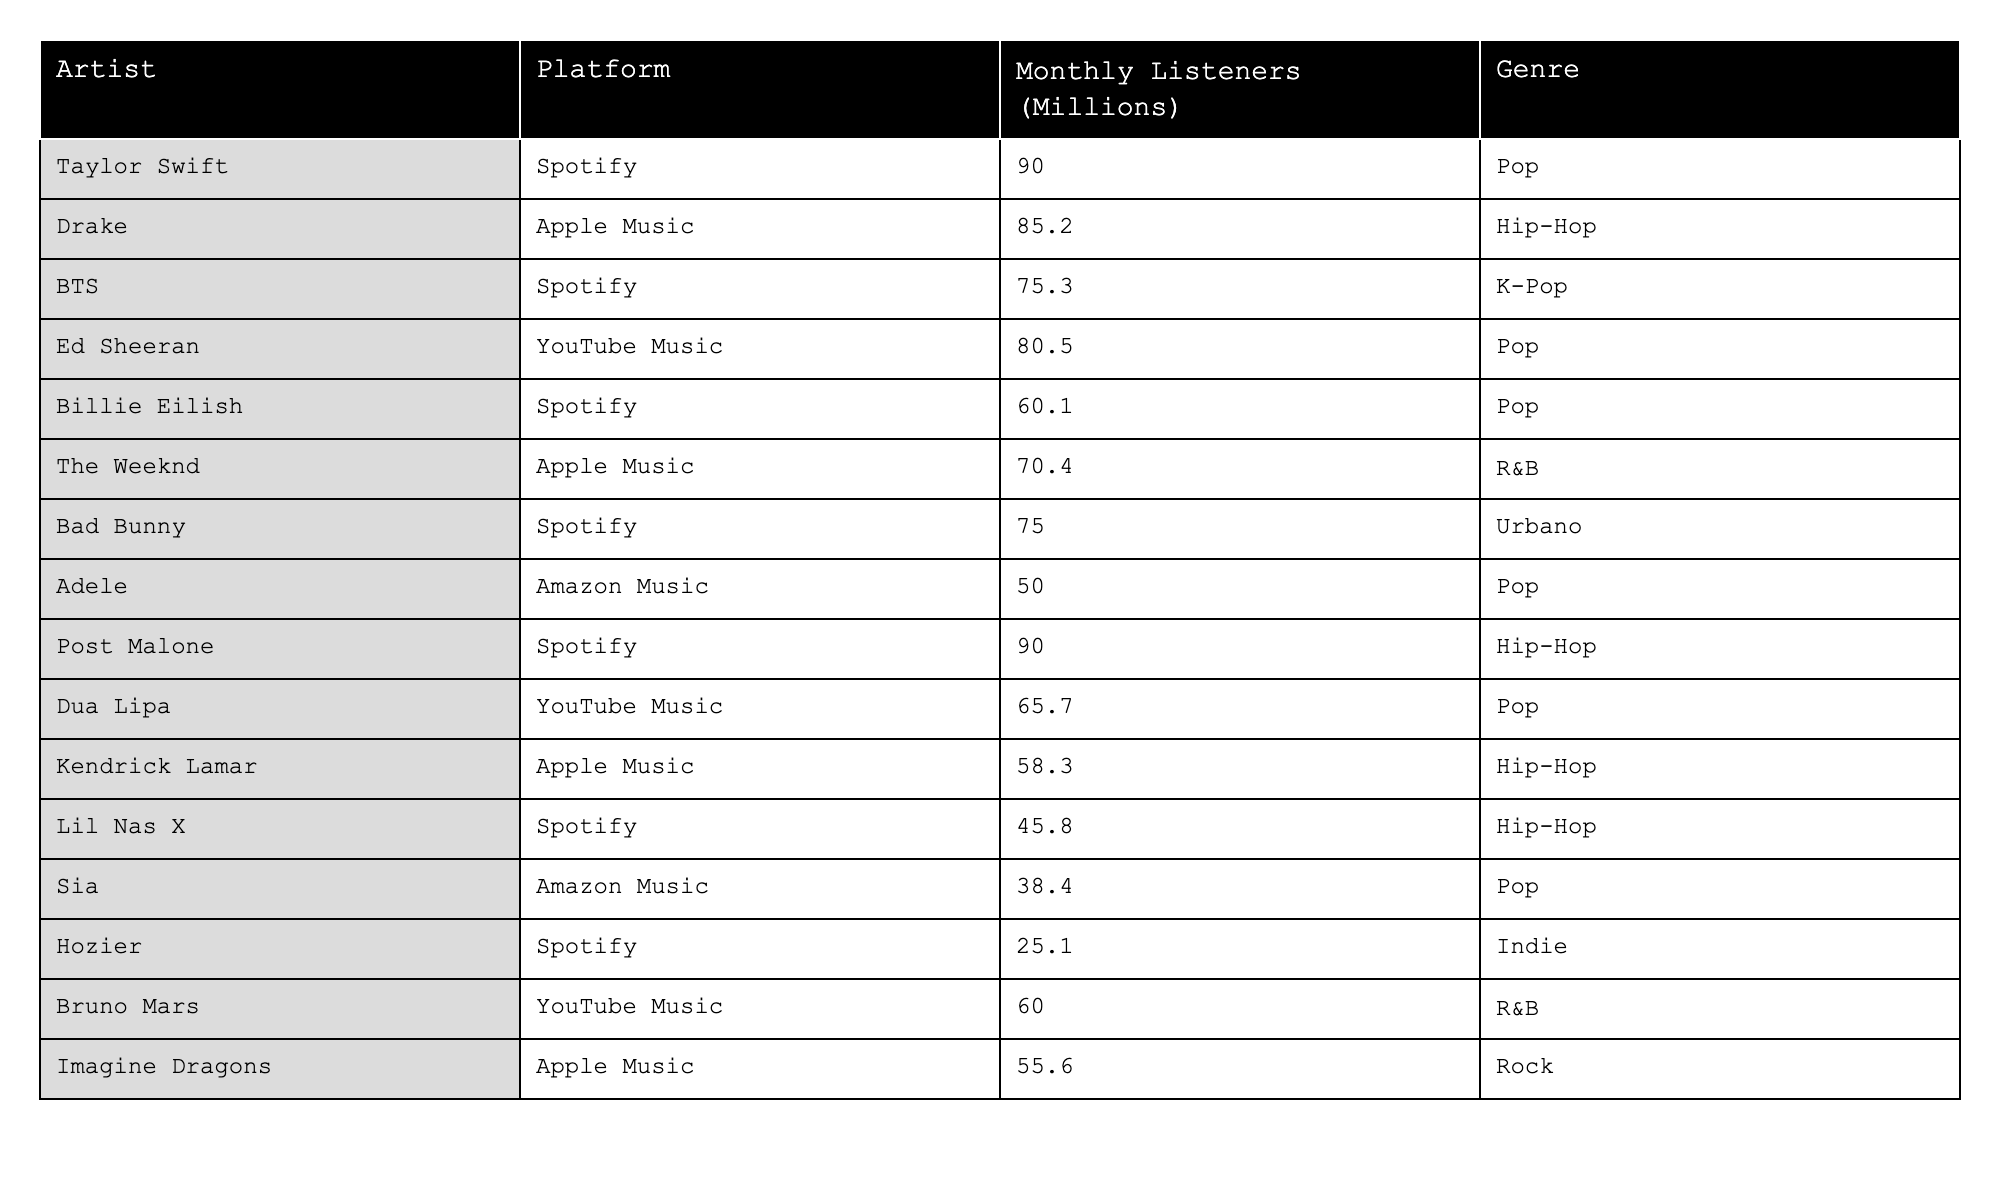What is the highest number of monthly listeners among the artists listed? By examining the Monthly Listeners column, Taylor Swift has the highest value of 90.0 million.
Answer: 90.0 million Which streaming platform has the artist with the lowest monthly listeners? In the table, Hozier, who has the lowest monthly listeners at 25.1 million, is associated with Spotify.
Answer: Spotify What is the difference in monthly listeners between Ed Sheeran and Billie Eilish? Ed Sheeran has 80.5 million listeners and Billie Eilish has 60.1 million listeners. The difference is 80.5 - 60.1 = 20.4 million.
Answer: 20.4 million Is there an artist on YouTube Music with more monthly listeners than those on Amazon Music? Yes, Ed Sheeran on YouTube Music has 80.5 million listeners, while Adele on Amazon Music has 50.0 million listeners.
Answer: Yes What is the average monthly listeners for all Hip-Hop artists listed? The Hip-Hop artists are Drake (85.2), Post Malone (90.0), and Kendrick Lamar (58.3). Their sum is 85.2 + 90.0 + 58.3 = 233.5, and there are 3 artists, so the average is 233.5 / 3 = 77.83 million.
Answer: 77.83 million Which genre has the highest average monthly listeners? The genres with the listeners are Pop (90.0, 80.5, 60.1, 65.7, 50.0 = 346.3), Hip-Hop (85.2, 90.0, 58.3 = 233.5), K-Pop (75.3), R&B (70.4, 60.0 = 130.4), Urbano (75.0), and Indie (25.1). The Pop average is 346.3 / 5 = 69.26, Hip-Hop is 233.5 / 3 = 77.83, K-Pop is 75.3, R&B is 130.4 / 2 = 65.2, Urbano is 75.0, and Indie is 25.1. Pop has the highest average of 69.26 million.
Answer: Pop How many artists have more than 70 million monthly listeners? The artists with more than 70 million listeners are Taylor Swift (90.0), Drake (85.2), Post Malone (90.0), and Bad Bunny (75.0). This totals to 4 artists.
Answer: 4 What is the total number of monthly listeners for all artists on Spotify? The Spotify artists and their listeners are Taylor Swift (90.0), BTS (75.3), Billie Eilish (60.1), Bad Bunny (75.0), Lil Nas X (45.8), Hozier (25.1). Summing these gives 90.0 + 75.3 + 60.1 + 75.0 + 45.8 + 25.1 = 371.3 million.
Answer: 371.3 million Which artist's monthly listeners are nearest to 50 million? Adele has 50.0 million listeners, which is exactly 50 million.
Answer: Adele How does the average monthly listeners for YouTube Music compare to that on Amazon Music? YouTube Music has Ed Sheeran (80.5) and Dua Lipa (65.7), yielding an average of (80.5 + 65.7) / 2 = 73.1 million. Amazon Music has Adele (50.0) and Sia (38.4) with an average of (50.0 + 38.4) / 2 = 44.2 million. The average for YouTube Music is higher.
Answer: YouTube Music is higher 